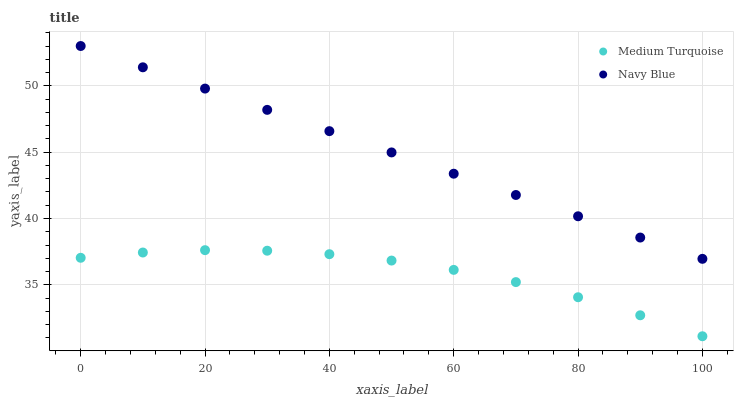Does Medium Turquoise have the minimum area under the curve?
Answer yes or no. Yes. Does Navy Blue have the maximum area under the curve?
Answer yes or no. Yes. Does Medium Turquoise have the maximum area under the curve?
Answer yes or no. No. Is Navy Blue the smoothest?
Answer yes or no. Yes. Is Medium Turquoise the roughest?
Answer yes or no. Yes. Is Medium Turquoise the smoothest?
Answer yes or no. No. Does Medium Turquoise have the lowest value?
Answer yes or no. Yes. Does Navy Blue have the highest value?
Answer yes or no. Yes. Does Medium Turquoise have the highest value?
Answer yes or no. No. Is Medium Turquoise less than Navy Blue?
Answer yes or no. Yes. Is Navy Blue greater than Medium Turquoise?
Answer yes or no. Yes. Does Medium Turquoise intersect Navy Blue?
Answer yes or no. No. 